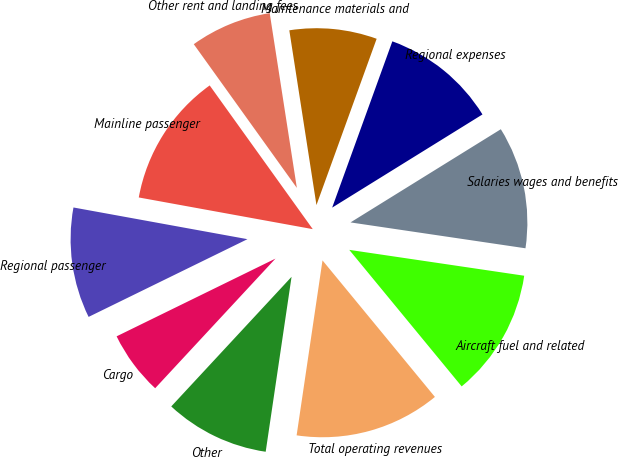Convert chart. <chart><loc_0><loc_0><loc_500><loc_500><pie_chart><fcel>Mainline passenger<fcel>Regional passenger<fcel>Cargo<fcel>Other<fcel>Total operating revenues<fcel>Aircraft fuel and related<fcel>Salaries wages and benefits<fcel>Regional expenses<fcel>Maintenance materials and<fcel>Other rent and landing fees<nl><fcel>12.23%<fcel>10.11%<fcel>5.85%<fcel>9.57%<fcel>13.3%<fcel>11.7%<fcel>11.17%<fcel>10.64%<fcel>7.98%<fcel>7.45%<nl></chart> 